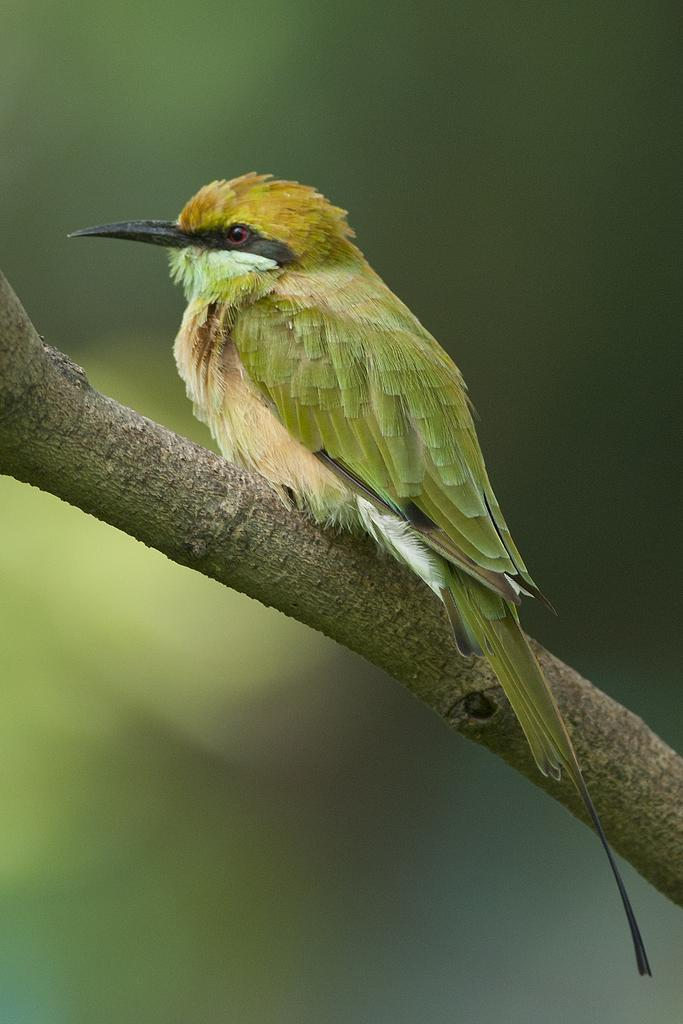What type of animal can be seen in the image? There is a bird in the image. Where is the bird located? The bird is on a branch of a tree. Can you describe the background of the image? The background of the image is blurred. What decisions is the committee making about the bird in the image? There is no committee present in the image, and therefore no decisions are being made about the bird. 